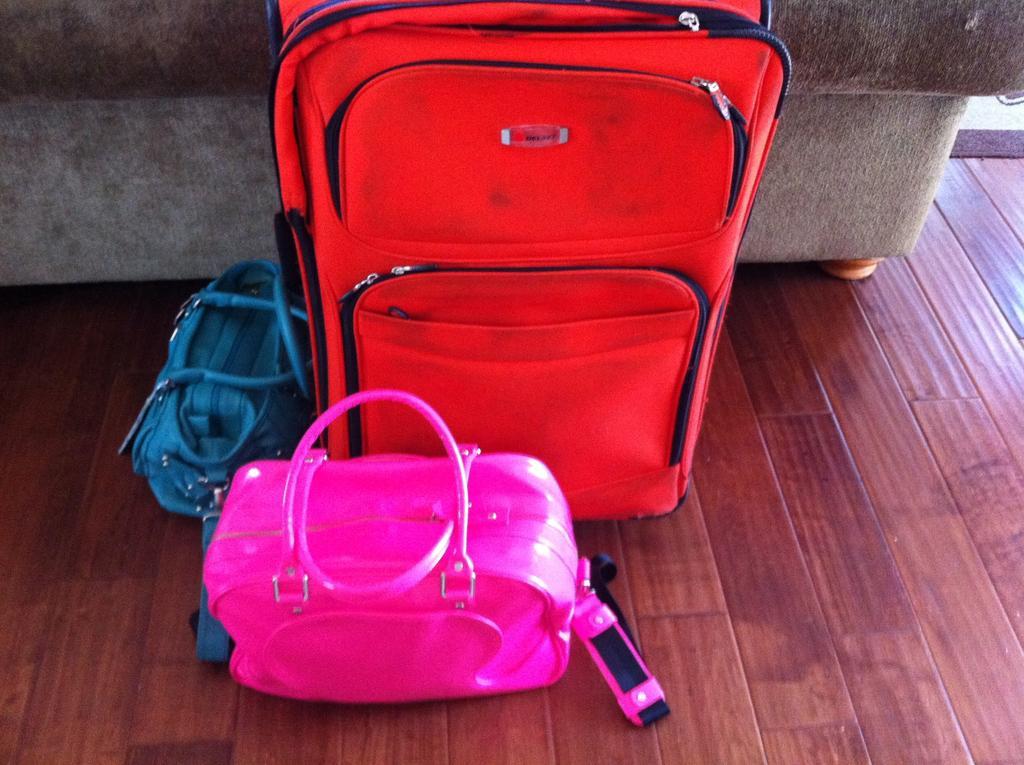How would you summarize this image in a sentence or two? There is a red travel bag and a blue and pink handbags and there is a sofa behind it. 